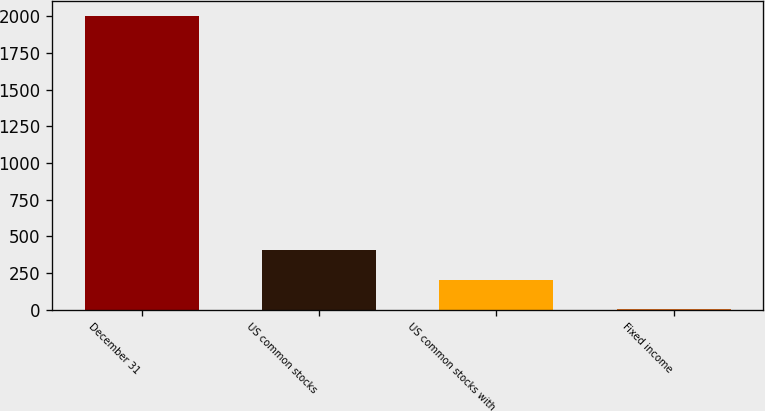<chart> <loc_0><loc_0><loc_500><loc_500><bar_chart><fcel>December 31<fcel>US common stocks<fcel>US common stocks with<fcel>Fixed income<nl><fcel>2004<fcel>404.8<fcel>204.9<fcel>5<nl></chart> 